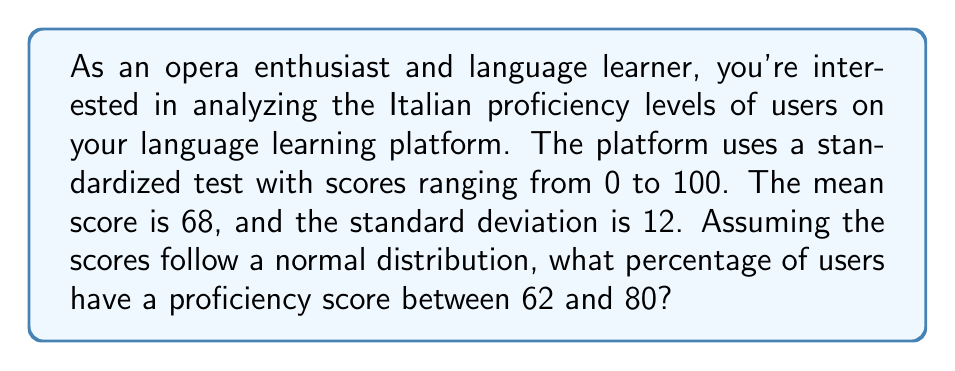Show me your answer to this math problem. To solve this problem, we'll use the properties of the normal distribution and the z-score formula. Here are the steps:

1. Identify the given information:
   - Mean ($\mu$) = 68
   - Standard deviation ($\sigma$) = 12
   - Lower bound ($x_1$) = 62
   - Upper bound ($x_2$) = 80

2. Calculate the z-scores for both bounds:
   
   $z = \frac{x - \mu}{\sigma}$

   For the lower bound: $z_1 = \frac{62 - 68}{12} = -0.5$
   For the upper bound: $z_2 = \frac{80 - 68}{12} = 1$

3. Find the area under the standard normal curve between these z-scores:
   
   Area = $P(z_1 < Z < z_2) = P(-0.5 < Z < 1)$
   
   This can be calculated using a standard normal table or a calculator:
   
   $P(Z < 1) - P(Z < -0.5) = 0.8413 - 0.3085 = 0.5328$

4. Convert the result to a percentage:
   
   $0.5328 \times 100\% = 53.28\%$

Therefore, approximately 53.28% of users have a proficiency score between 62 and 80.
Answer: 53.28% 